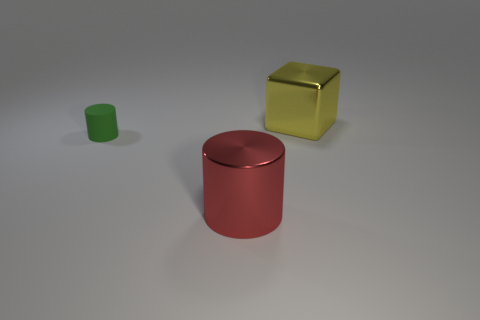Add 2 big brown matte objects. How many big brown matte objects exist? 2 Add 2 green spheres. How many objects exist? 5 Subtract 0 purple cylinders. How many objects are left? 3 Subtract all cylinders. How many objects are left? 1 Subtract 2 cylinders. How many cylinders are left? 0 Subtract all purple blocks. Subtract all gray balls. How many blocks are left? 1 Subtract all green cubes. How many green cylinders are left? 1 Subtract all matte objects. Subtract all small cylinders. How many objects are left? 1 Add 2 red things. How many red things are left? 3 